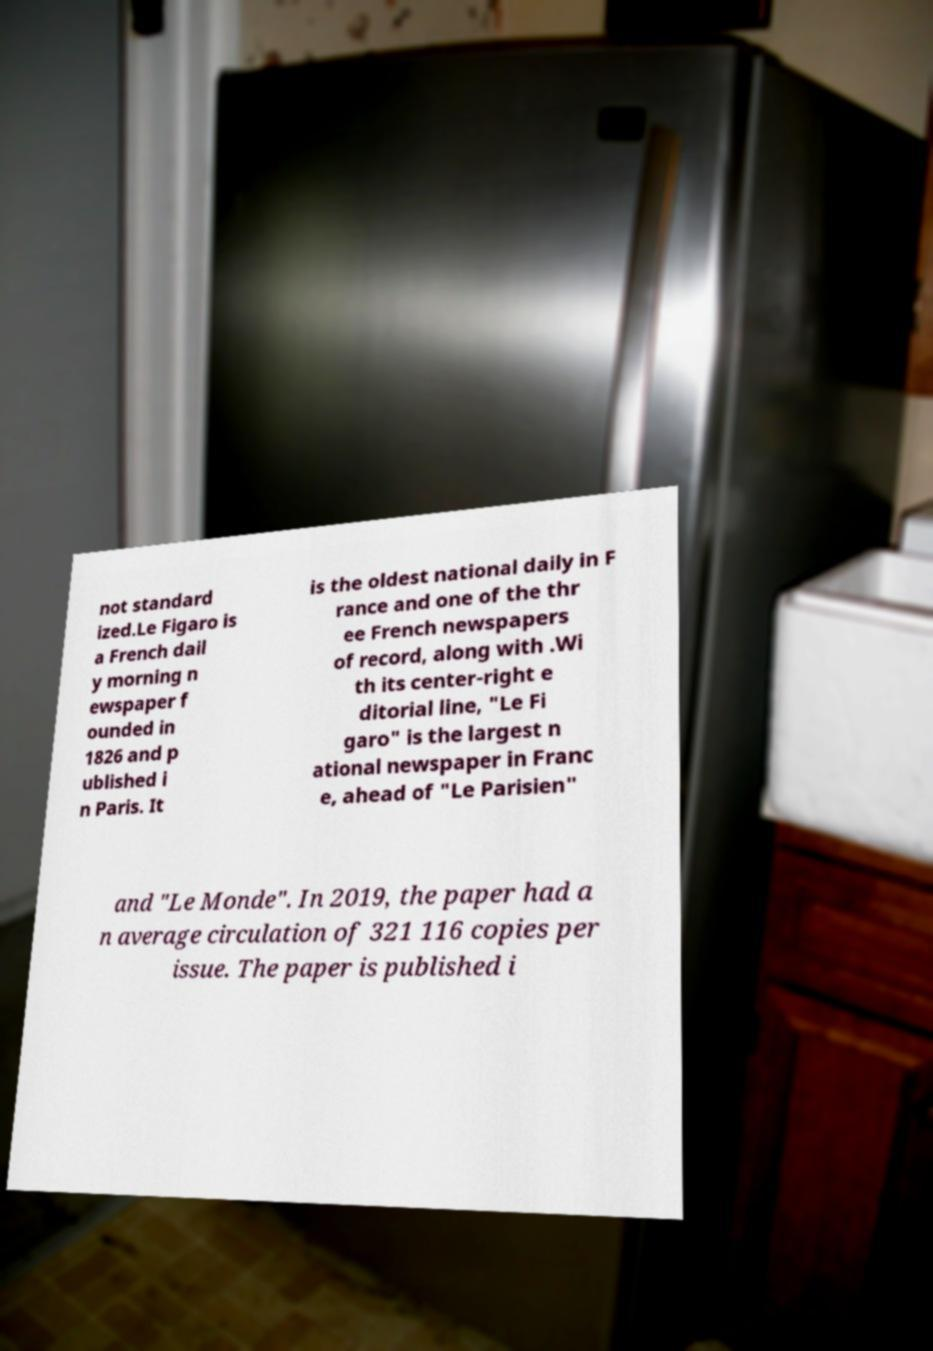Could you extract and type out the text from this image? not standard ized.Le Figaro is a French dail y morning n ewspaper f ounded in 1826 and p ublished i n Paris. It is the oldest national daily in F rance and one of the thr ee French newspapers of record, along with .Wi th its center-right e ditorial line, "Le Fi garo" is the largest n ational newspaper in Franc e, ahead of "Le Parisien" and "Le Monde". In 2019, the paper had a n average circulation of 321 116 copies per issue. The paper is published i 